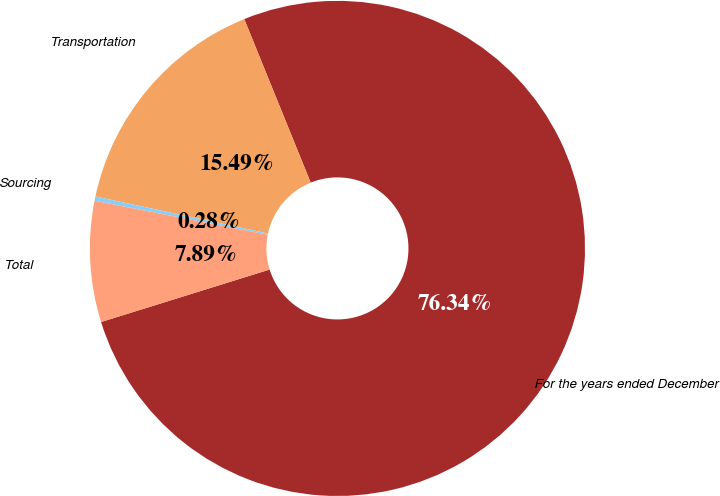<chart> <loc_0><loc_0><loc_500><loc_500><pie_chart><fcel>For the years ended December<fcel>Transportation<fcel>Sourcing<fcel>Total<nl><fcel>76.33%<fcel>15.49%<fcel>0.28%<fcel>7.89%<nl></chart> 